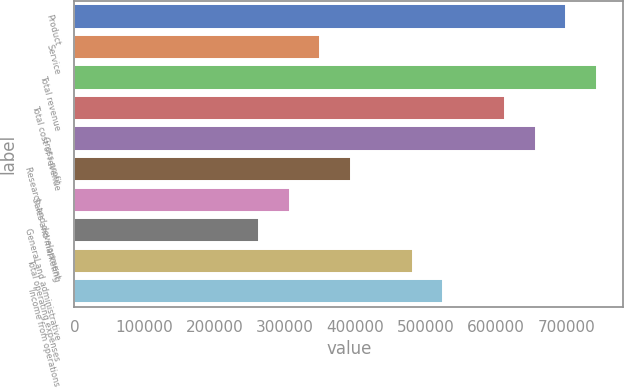<chart> <loc_0><loc_0><loc_500><loc_500><bar_chart><fcel>Product<fcel>Service<fcel>Total revenue<fcel>Total cost of revenue<fcel>Gross profit<fcel>Research and development<fcel>Sales and marketing<fcel>General and administrative<fcel>Total operating expenses<fcel>Income from operations<nl><fcel>700212<fcel>350107<fcel>743975<fcel>612686<fcel>656449<fcel>393870<fcel>306344<fcel>262580<fcel>481396<fcel>525159<nl></chart> 